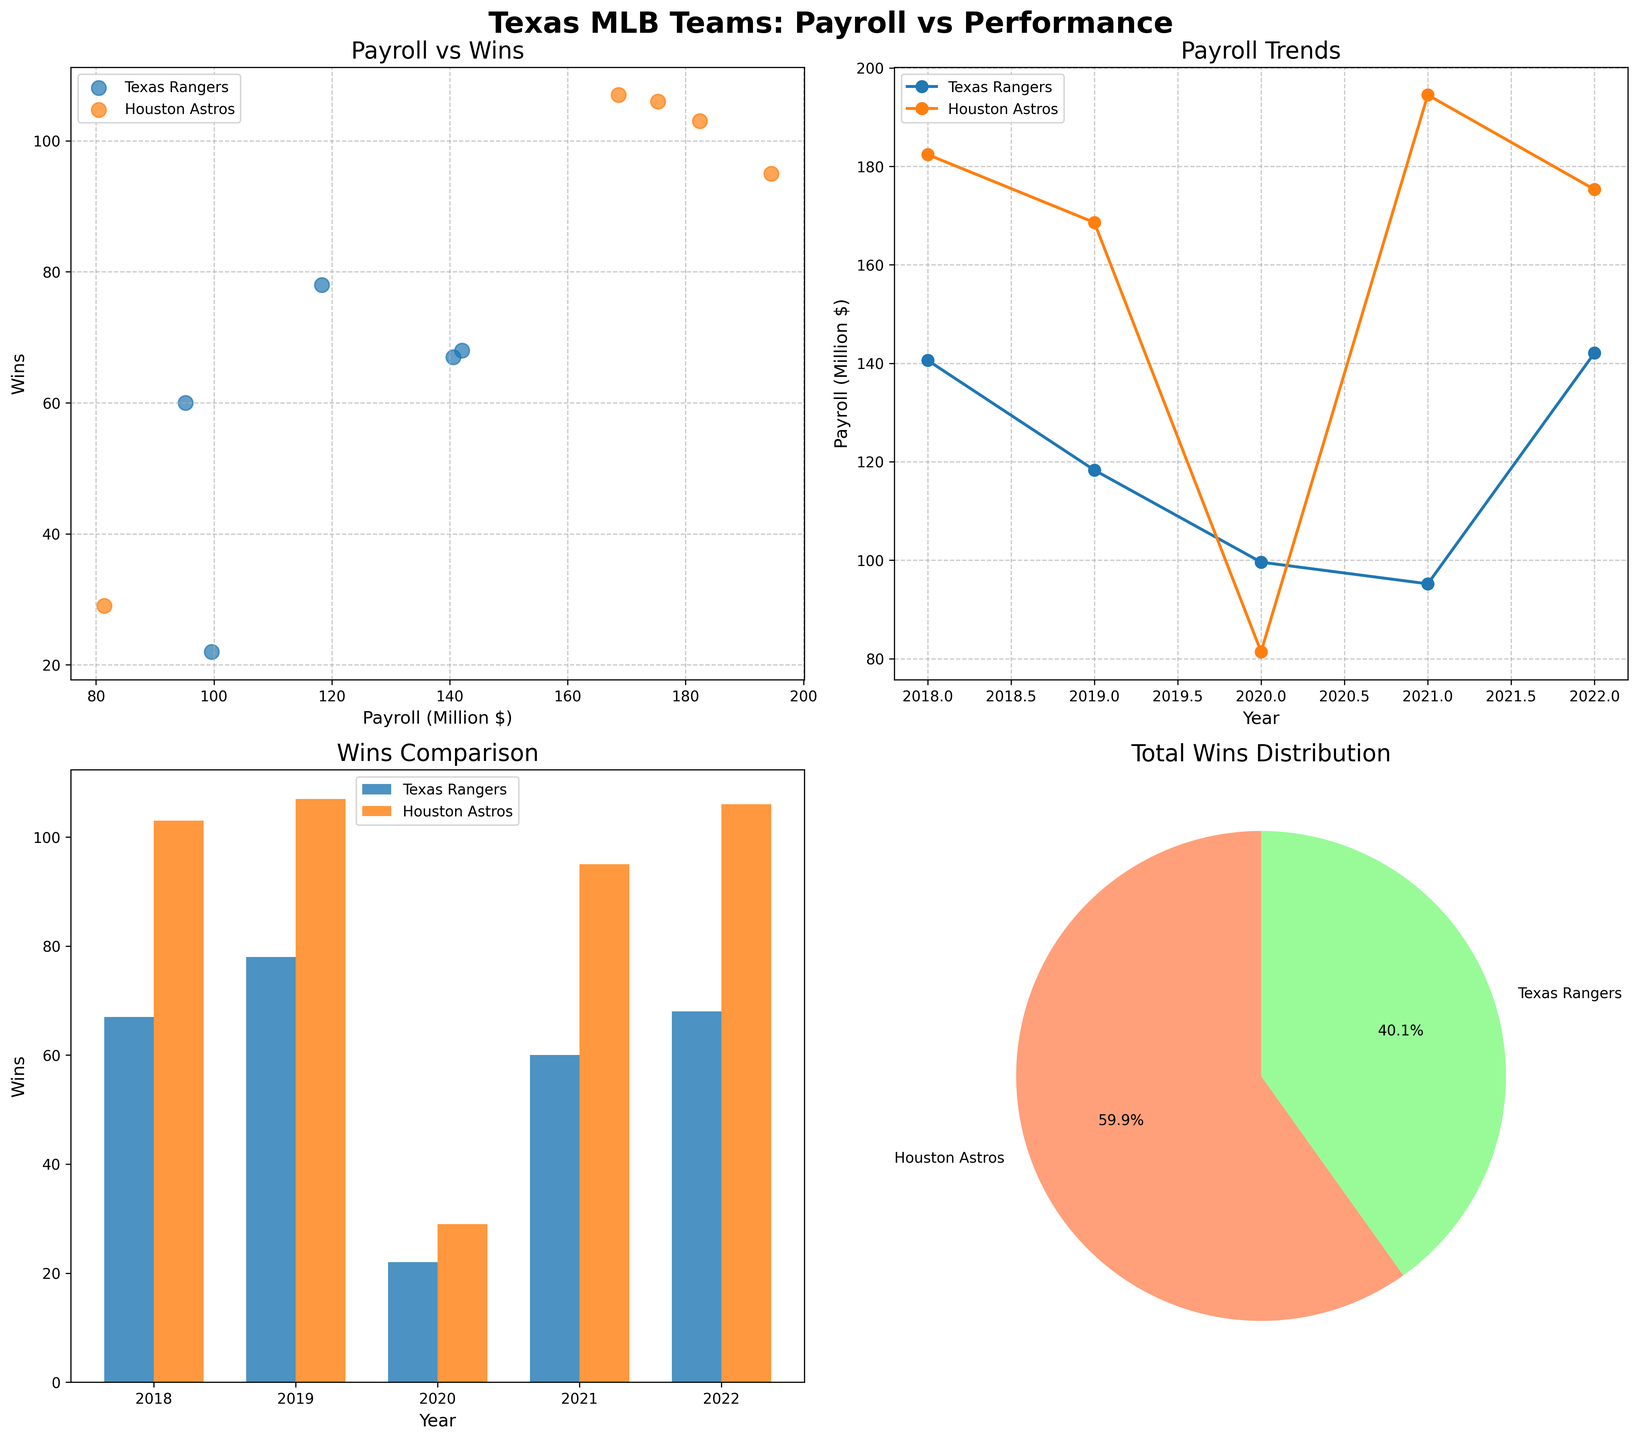Which team had a higher payroll in 2020? In the line plot, check the Payroll values for the year 2020. The Texas Rangers have a payroll of 99.6 million dollars, while the Houston Astros have a payroll of 81.4 million dollars.
Answer: Texas Rangers How did the number of wins for the Texas Rangers compare between 2018 and 2022? In the bar plot, look at the heights of the bars for the Texas Rangers in the years 2018 and 2022. In 2018, the Texas Rangers had 67 wins, while in 2022, they had 68 wins.
Answer: They increased by 1 win What's the relationship between the payroll and wins for the Houston Astros? In the scatter plot, look at the spatial distribution of the Houston Astros data points. Generally, as the payroll increases, the number of wins also increases.
Answer: Positive correlation Which team's wins contributed the most to the total wins distribution? In the pie chart, check the labels and percentages attributed to each team. The Houston Astros have a larger portion of the pie chart compared to the Texas Rangers.
Answer: Houston Astros What was the trend in payroll for the Texas Rangers over the years? In the line plot, observe the Texas Rangers' line from 2018 to 2022. The payroll trend starts relatively high in 2018, decreases until 2021, and then increases again in 2022.
Answer: Decreasing, then increasing How many years showed the Houston Astros having a payroll higher than 150 million dollars? In the line plot, count the number of points for the Houston Astros where the payroll exceeds 150 million dollars. This occurs in the years 2018, 2019, 2021, and 2022.
Answer: 4 years Compare the highest and lowest payroll for the Texas Rangers among the years shown. In the line plot for the Texas Rangers, determine the highest and lowest payroll values. The highest payroll is 142.1 million in 2022 and the lowest is 95.2 million in 2021.
Answer: Highest=142.1, Lowest=95.2 What's the average number of wins for the Houston Astros from 2018 to 2022? Sum the wins for the Houston Astros across the years 2018 (103), 2019 (107), 2020 (29), 2021 (95), and 2022 (106), then divide by the number of years (5). The total is 440, so the average is 440 / 5 = 88.
Answer: 88 